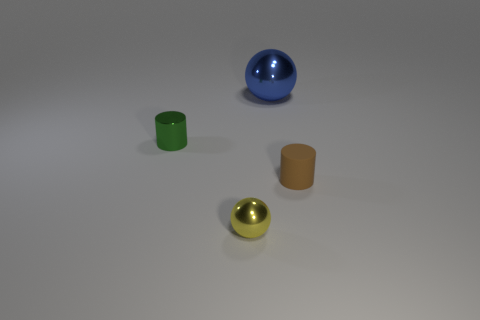Add 1 large metal balls. How many objects exist? 5 Add 2 green cylinders. How many green cylinders are left? 3 Add 1 large red metal cubes. How many large red metal cubes exist? 1 Subtract 0 red spheres. How many objects are left? 4 Subtract all matte objects. Subtract all tiny rubber things. How many objects are left? 2 